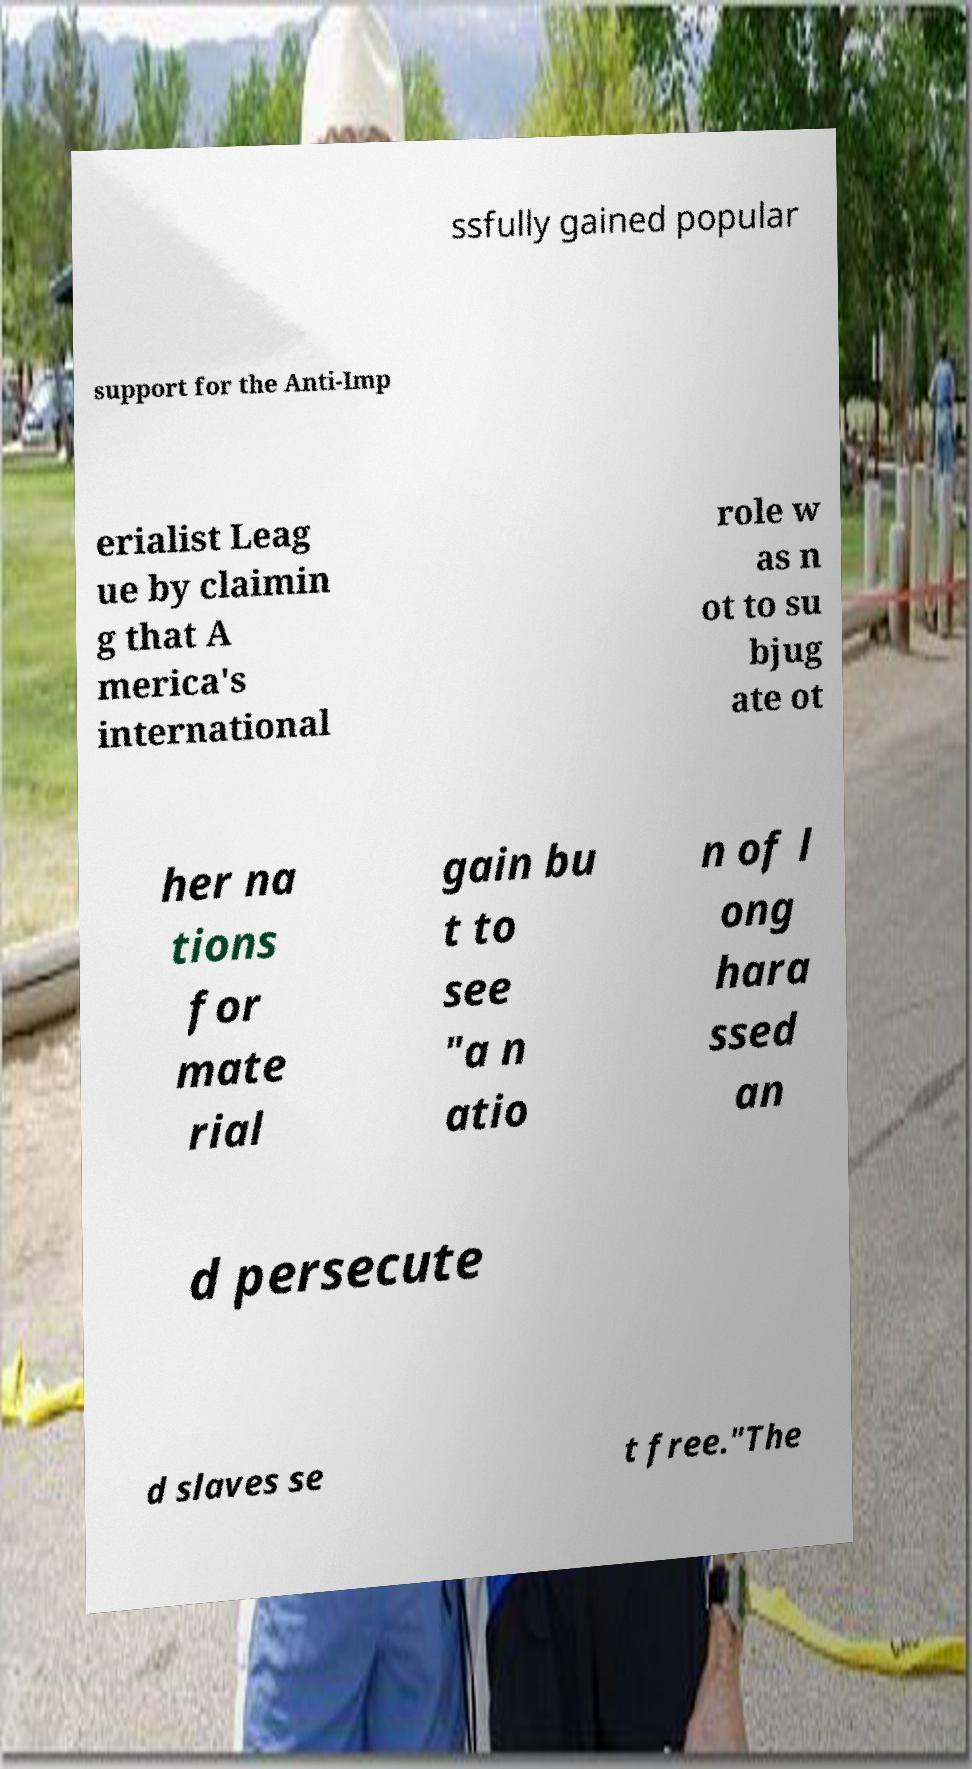There's text embedded in this image that I need extracted. Can you transcribe it verbatim? ssfully gained popular support for the Anti-Imp erialist Leag ue by claimin g that A merica's international role w as n ot to su bjug ate ot her na tions for mate rial gain bu t to see "a n atio n of l ong hara ssed an d persecute d slaves se t free."The 